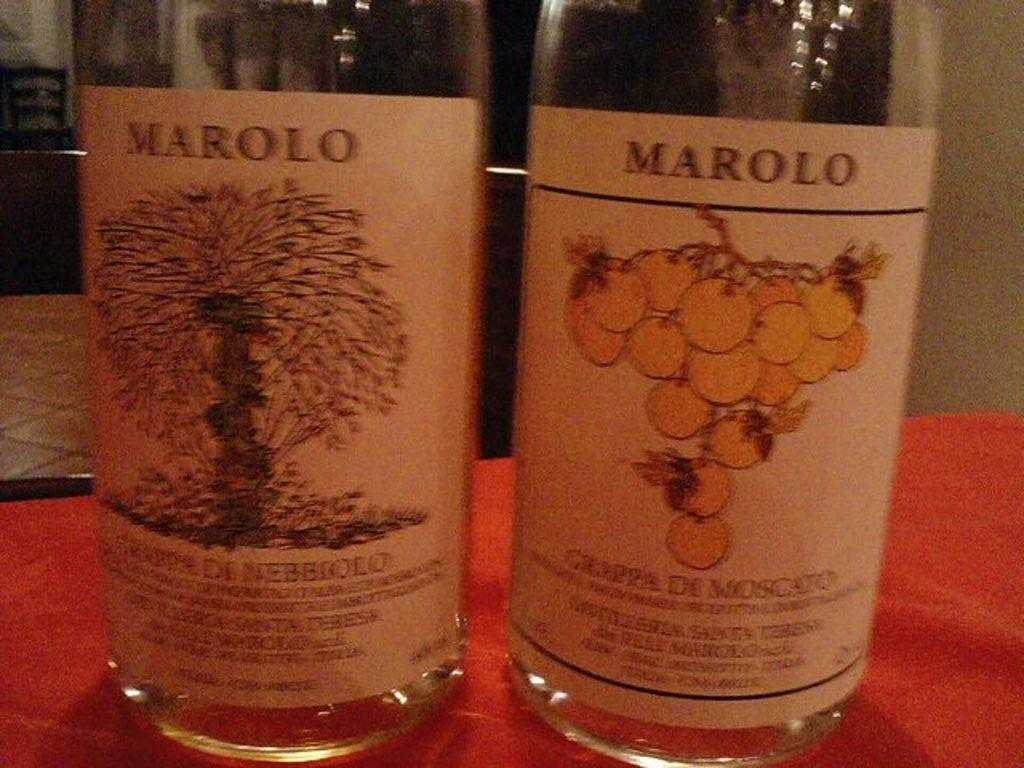<image>
Render a clear and concise summary of the photo. Two clear bottles of Marolo with tree and grape illustrations on them. 